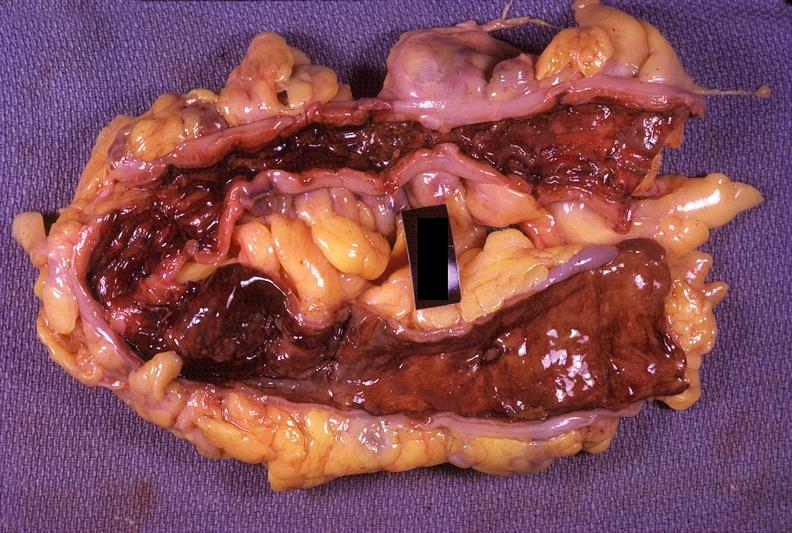where does this belong to?
Answer the question using a single word or phrase. Gastrointestinal system 